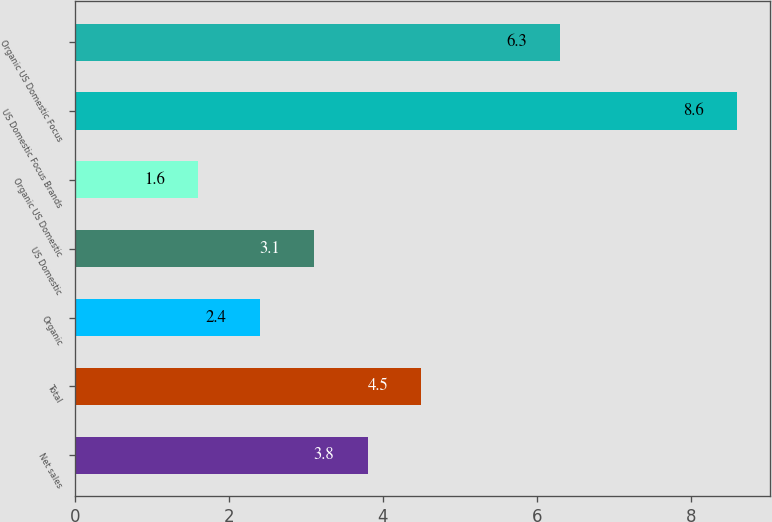Convert chart. <chart><loc_0><loc_0><loc_500><loc_500><bar_chart><fcel>Net sales<fcel>Total<fcel>Organic<fcel>US Domestic<fcel>Organic US Domestic<fcel>US Domestic Focus Brands<fcel>Organic US Domestic Focus<nl><fcel>3.8<fcel>4.5<fcel>2.4<fcel>3.1<fcel>1.6<fcel>8.6<fcel>6.3<nl></chart> 